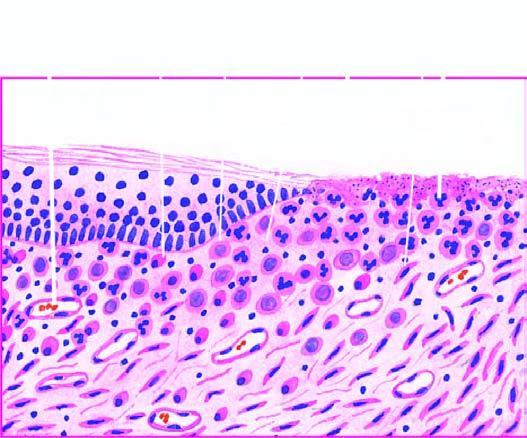does ctive granulation tissue have inflammatory cell infiltrate, newly formed blood vessels and young fibrous tissue in loose matrix?
Answer the question using a single word or phrase. Yes 